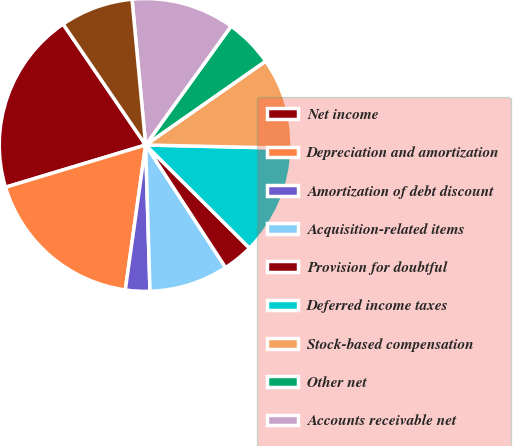<chart> <loc_0><loc_0><loc_500><loc_500><pie_chart><fcel>Net income<fcel>Depreciation and amortization<fcel>Amortization of debt discount<fcel>Acquisition-related items<fcel>Provision for doubtful<fcel>Deferred income taxes<fcel>Stock-based compensation<fcel>Other net<fcel>Accounts receivable net<fcel>Inventories<nl><fcel>20.13%<fcel>18.12%<fcel>2.69%<fcel>8.73%<fcel>3.36%<fcel>12.08%<fcel>10.07%<fcel>5.37%<fcel>11.41%<fcel>8.05%<nl></chart> 